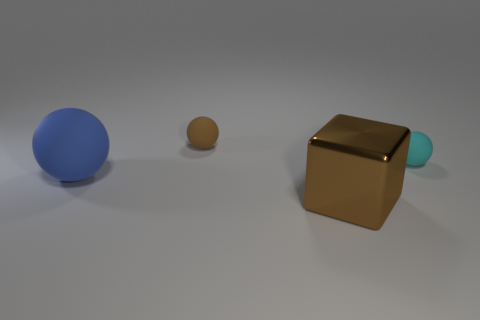What shape is the thing that is right of the big blue ball and to the left of the metallic thing?
Provide a short and direct response. Sphere. Are there any tiny matte balls that have the same color as the big metal block?
Ensure brevity in your answer.  Yes. There is a rubber thing to the right of the tiny matte object to the left of the big metallic object; what color is it?
Keep it short and to the point. Cyan. What size is the rubber object behind the tiny matte ball that is to the right of the brown object that is in front of the big blue ball?
Provide a short and direct response. Small. Is the material of the tiny brown ball the same as the large object that is right of the big rubber object?
Keep it short and to the point. No. There is a blue sphere that is made of the same material as the tiny cyan thing; what is its size?
Offer a very short reply. Large. Is there another matte object that has the same shape as the large matte object?
Make the answer very short. Yes. How many things are either blocks that are to the left of the cyan thing or green metallic balls?
Provide a succinct answer. 1. Is the color of the big thing that is right of the large blue matte thing the same as the tiny matte thing that is behind the cyan thing?
Provide a succinct answer. Yes. What is the size of the metal thing?
Ensure brevity in your answer.  Large. 